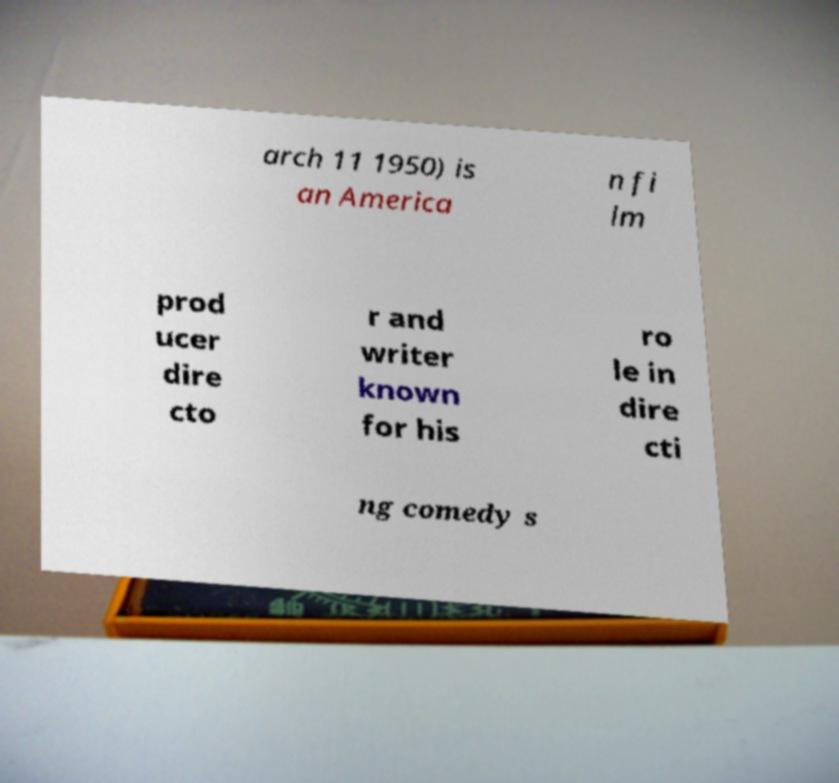For documentation purposes, I need the text within this image transcribed. Could you provide that? arch 11 1950) is an America n fi lm prod ucer dire cto r and writer known for his ro le in dire cti ng comedy s 